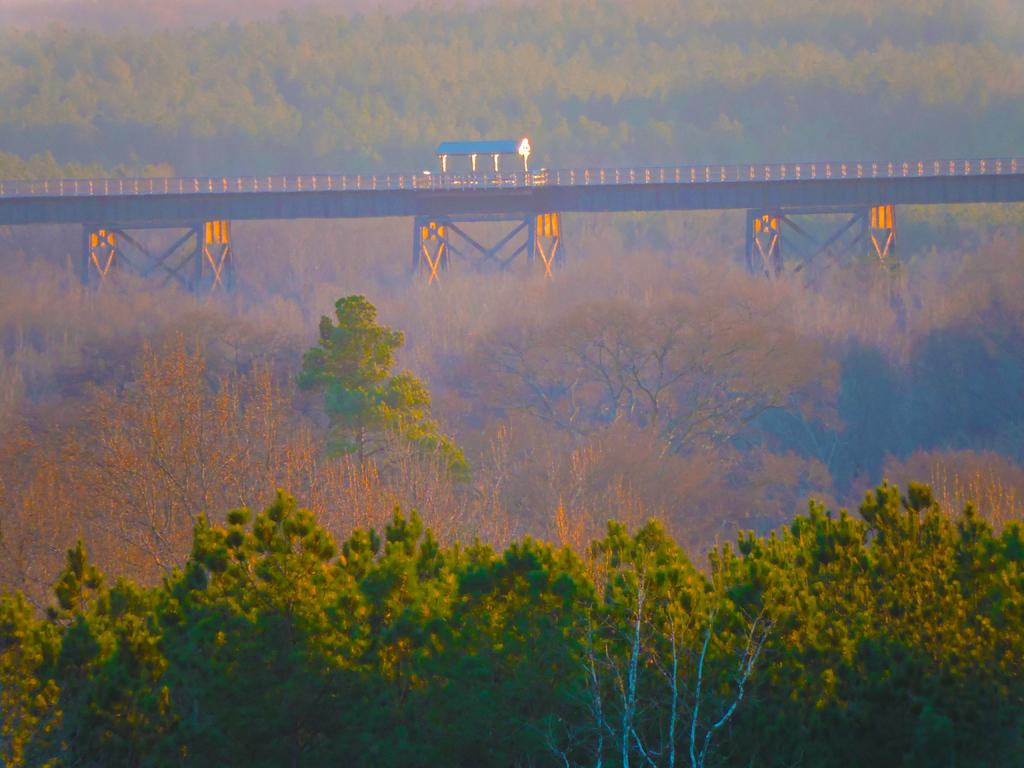What type of vegetation can be seen in the image? There are trees present in the image. What structure is visible that connects two areas? There is a bridge in the image. What type of small building can be seen in the image? There is a shed in the image. What type of hot beverage is being served in the image? There is no hot beverage present in the image; it features trees, a bridge, and a shed. How many cars can be seen in the image? There are no cars present in the image. 